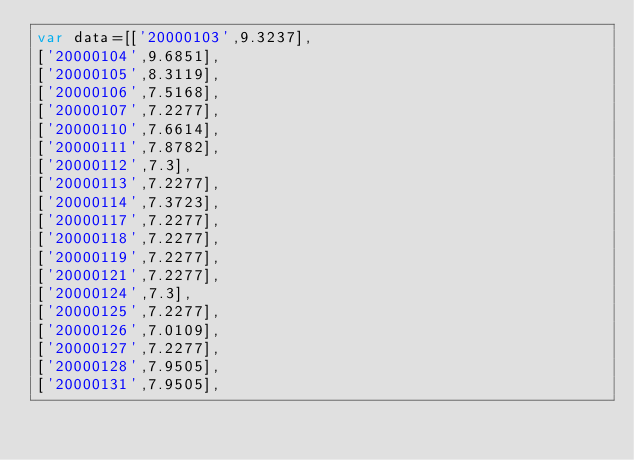<code> <loc_0><loc_0><loc_500><loc_500><_JavaScript_>var data=[['20000103',9.3237],
['20000104',9.6851],
['20000105',8.3119],
['20000106',7.5168],
['20000107',7.2277],
['20000110',7.6614],
['20000111',7.8782],
['20000112',7.3],
['20000113',7.2277],
['20000114',7.3723],
['20000117',7.2277],
['20000118',7.2277],
['20000119',7.2277],
['20000121',7.2277],
['20000124',7.3],
['20000125',7.2277],
['20000126',7.0109],
['20000127',7.2277],
['20000128',7.9505],
['20000131',7.9505],</code> 